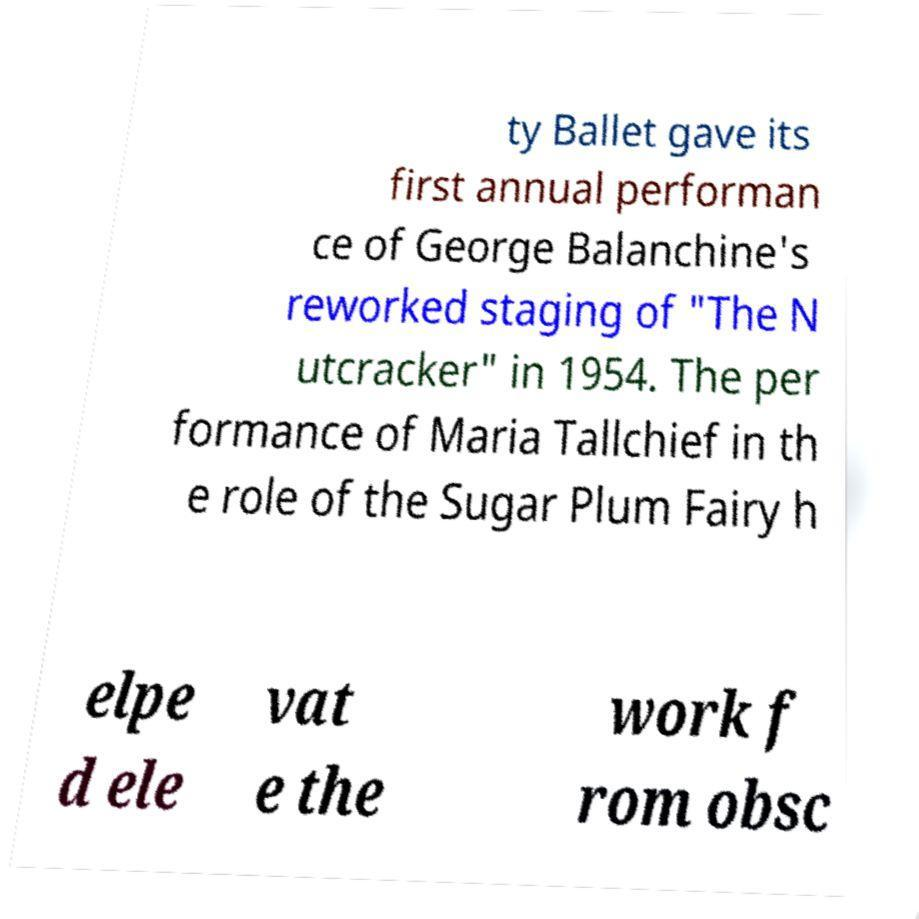There's text embedded in this image that I need extracted. Can you transcribe it verbatim? ty Ballet gave its first annual performan ce of George Balanchine's reworked staging of "The N utcracker" in 1954. The per formance of Maria Tallchief in th e role of the Sugar Plum Fairy h elpe d ele vat e the work f rom obsc 